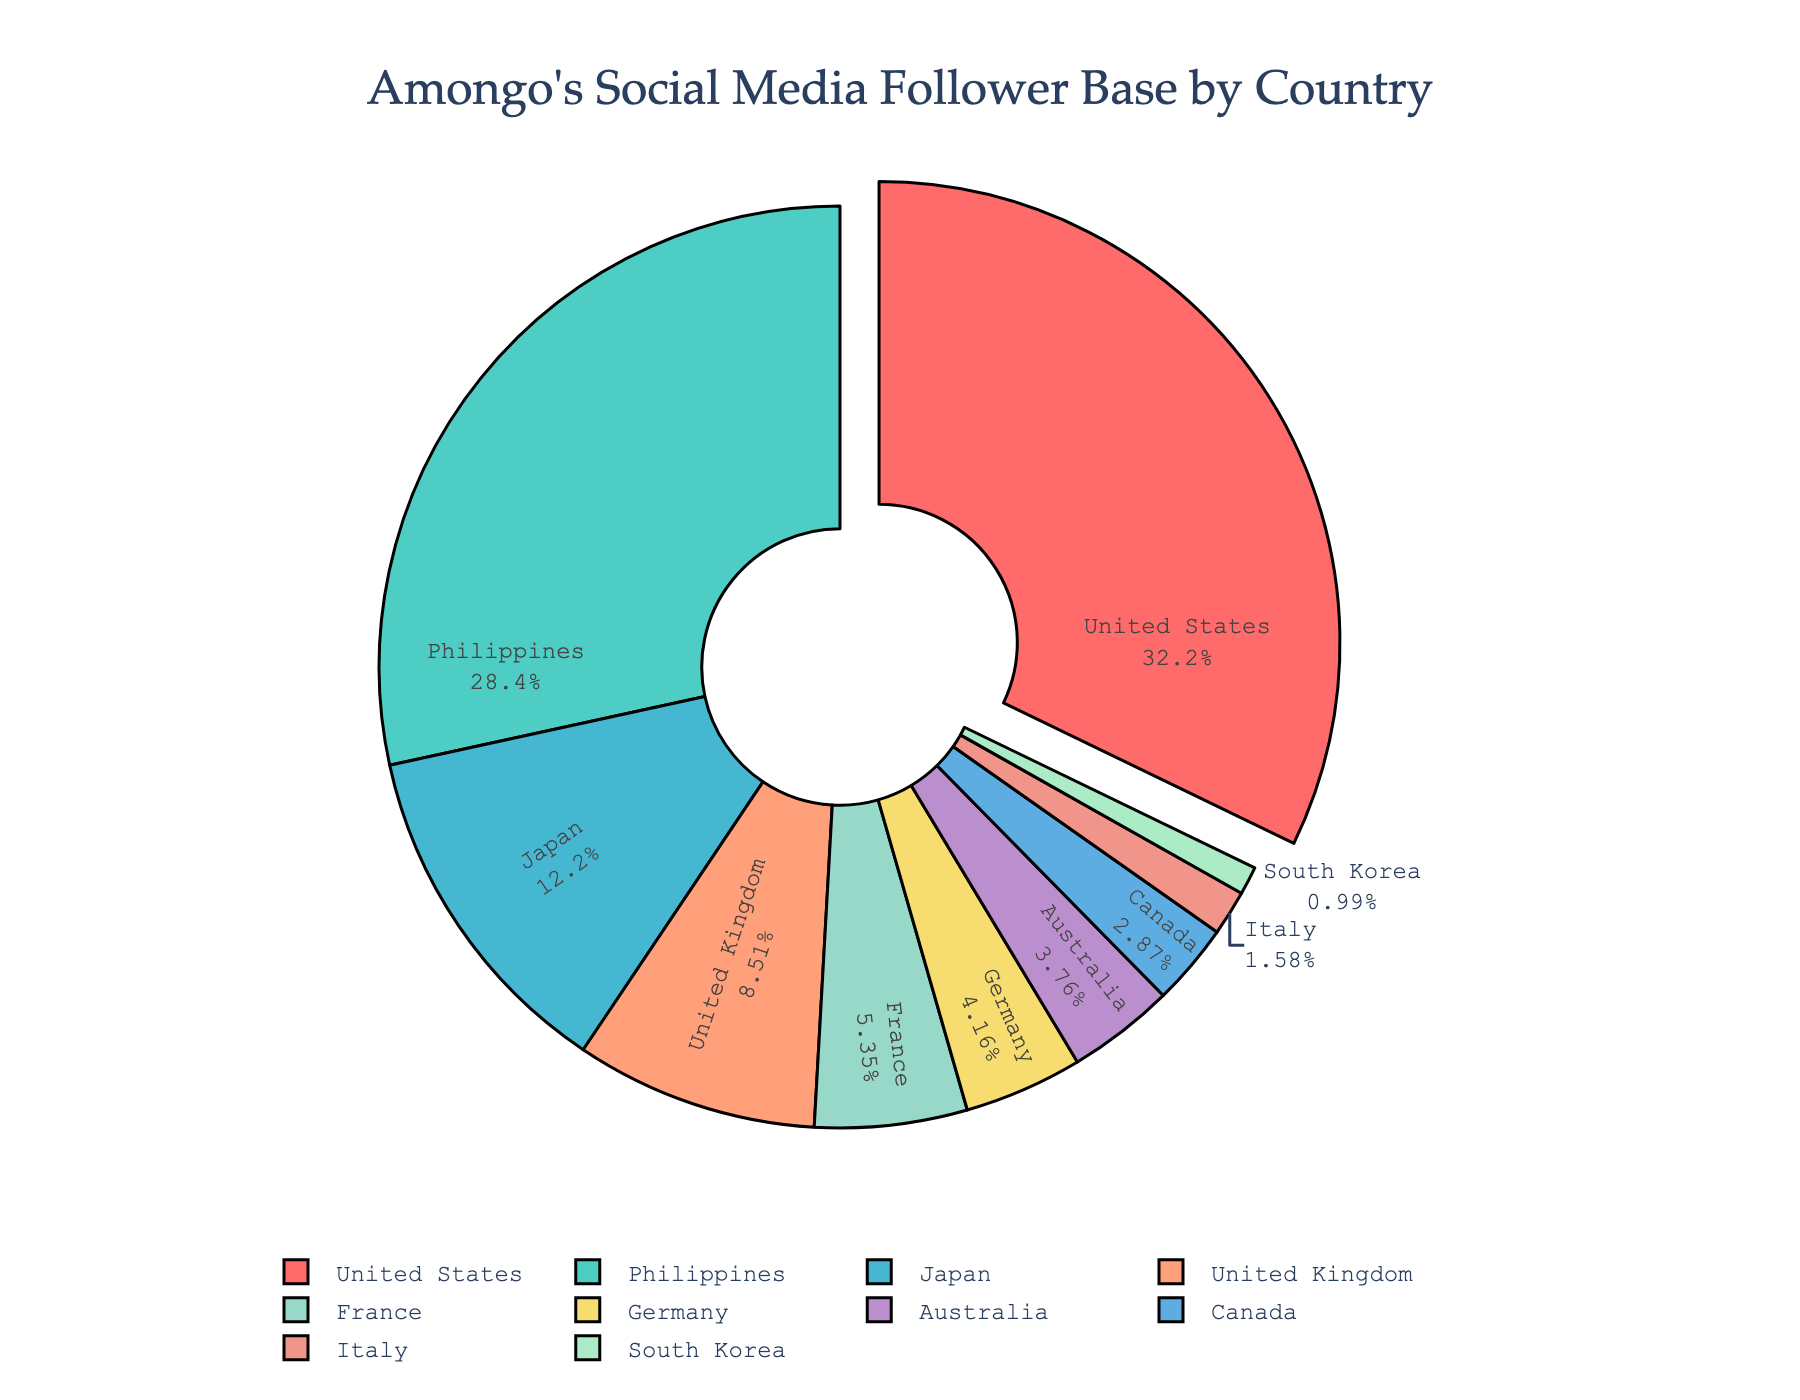Which country has the largest percentage of Amongo's social media follower base? By observing the pie chart, we see that the United States slice is pulled out and also has the largest portion of the pie.
Answer: United States Which countries have a follower base percentage greater than 20%? By examining the labels and corresponding percentages on the pie chart, the United States with 32.5% and the Philippines with 28.7% are the only two countries with follower base percentages above 20%.
Answer: United States, Philippines How much larger is the United States follower base than Germany's? The percentages for the United States and Germany can be seen in the chart. The United States has 32.5% and Germany has 4.2%, so the difference is 32.5% - 4.2% = 28.3%.
Answer: 28.3% Which countries have a smaller follower base than Japan? The pie chart shows that Japan has 12.3%. Countries with smaller percentages than Japan are the United Kingdom (8.6%), France (5.4%), Germany (4.2%), Australia (3.8%), Canada (2.9%), Italy (1.6%), and South Korea (1.0%).
Answer: United Kingdom, France, Germany, Australia, Canada, Italy, South Korea What is the combined percentage of Amongo's followers from France, Germany, and Italy? The individual percentages from the pie chart are France (5.4%), Germany (4.2%), and Italy (1.6%). Adding these gives 5.4% + 4.2% + 1.6% = 11.2%.
Answer: 11.2% How does the percentage of followers from Japan compare to the United Kingdom? From the pie chart, Japan has 12.3% and the United Kingdom has 8.6%. Japan's follower percentage is higher.
Answer: Japan Which segment is represented by a green color and what is its percentage? By looking at the colors used in the pie chart, the green segment corresponds to the Philippines with a percentage of 28.7%.
Answer: Philippines, 28.7% How many countries have less than 5% of Amongo's followers? By counting the segments with percentages less than 5% on the pie chart, the countries are Germany (4.2%), Australia (3.8%), Canada (2.9%), Italy (1.6%), and South Korea (1.0%), totaling five countries.
Answer: 5 What is the difference between the follower percentage of the United Kingdom and France? From the pie chart, the United Kingdom has 8.6% and France has 5.4%. The difference is 8.6% - 5.4% = 3.2%.
Answer: 3.2% If Amongo wants to target marketing efforts to countries that collectively make up at least 50% of the follower base, which countries should be included? Checking the percentages on the pie chart, the United States (32.5%) and the Philippines (28.7%) together sum to 61.2%, which surpasses the 50% threshold.
Answer: United States, Philippines 